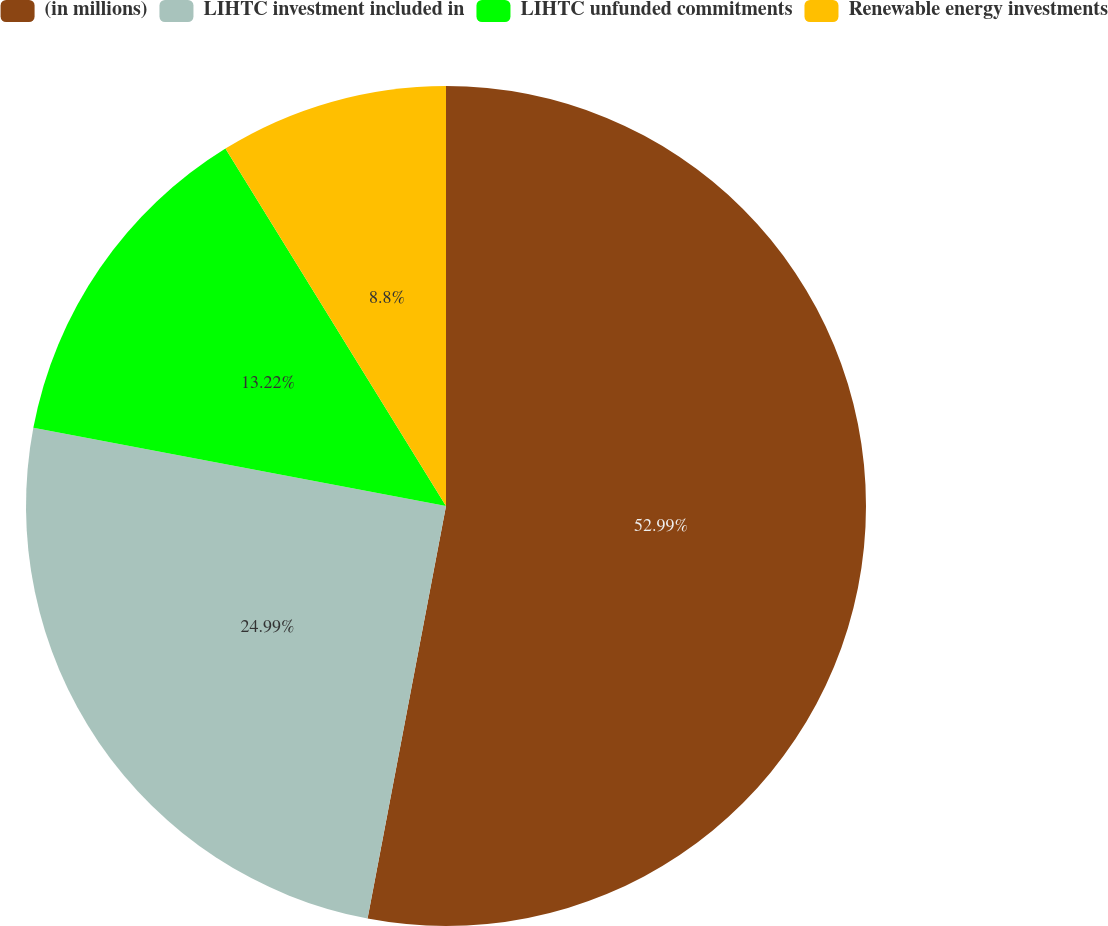Convert chart. <chart><loc_0><loc_0><loc_500><loc_500><pie_chart><fcel>(in millions)<fcel>LIHTC investment included in<fcel>LIHTC unfunded commitments<fcel>Renewable energy investments<nl><fcel>52.99%<fcel>24.99%<fcel>13.22%<fcel>8.8%<nl></chart> 